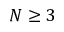Convert formula to latex. <formula><loc_0><loc_0><loc_500><loc_500>N \geq 3</formula> 